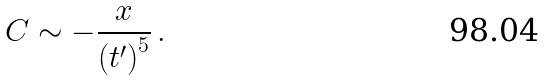<formula> <loc_0><loc_0><loc_500><loc_500>C \sim - \frac { x } { { ( t ^ { \prime } ) } ^ { 5 } } \, .</formula> 